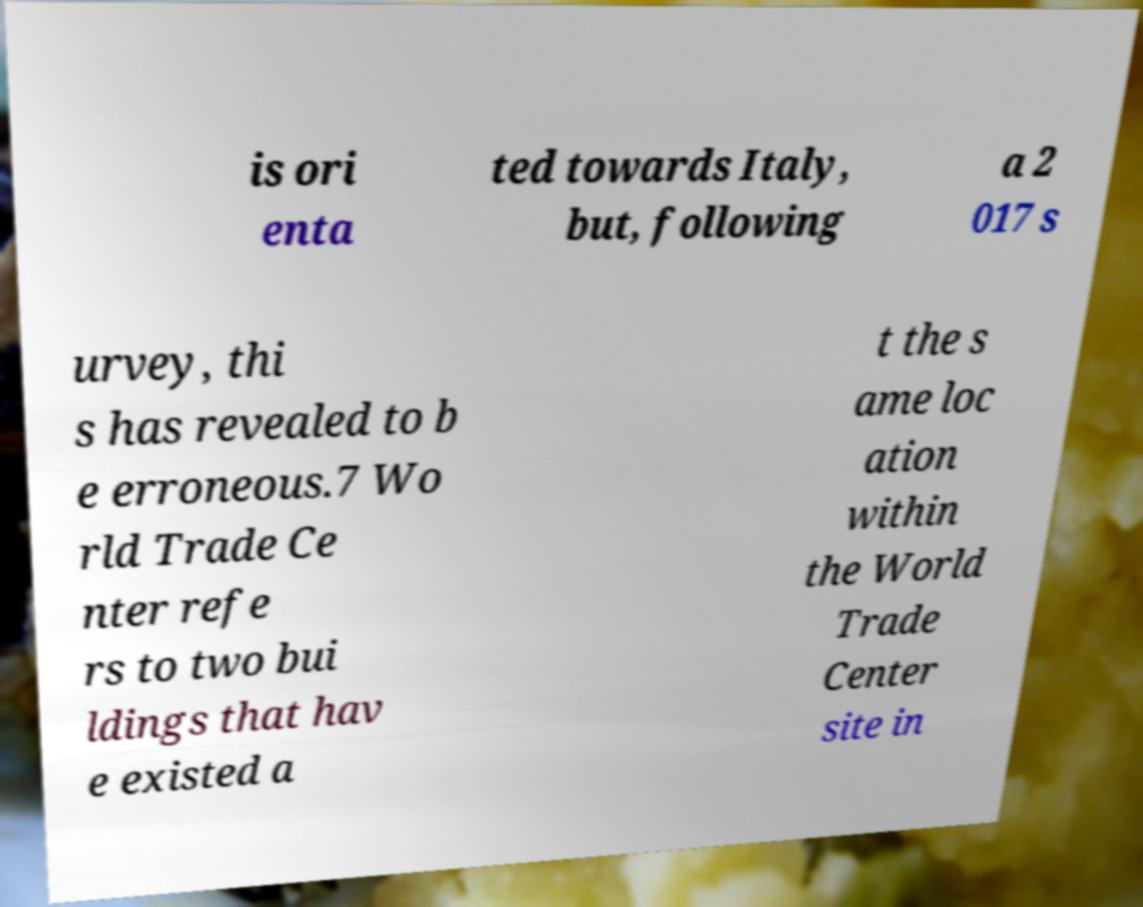Please read and relay the text visible in this image. What does it say? is ori enta ted towards Italy, but, following a 2 017 s urvey, thi s has revealed to b e erroneous.7 Wo rld Trade Ce nter refe rs to two bui ldings that hav e existed a t the s ame loc ation within the World Trade Center site in 